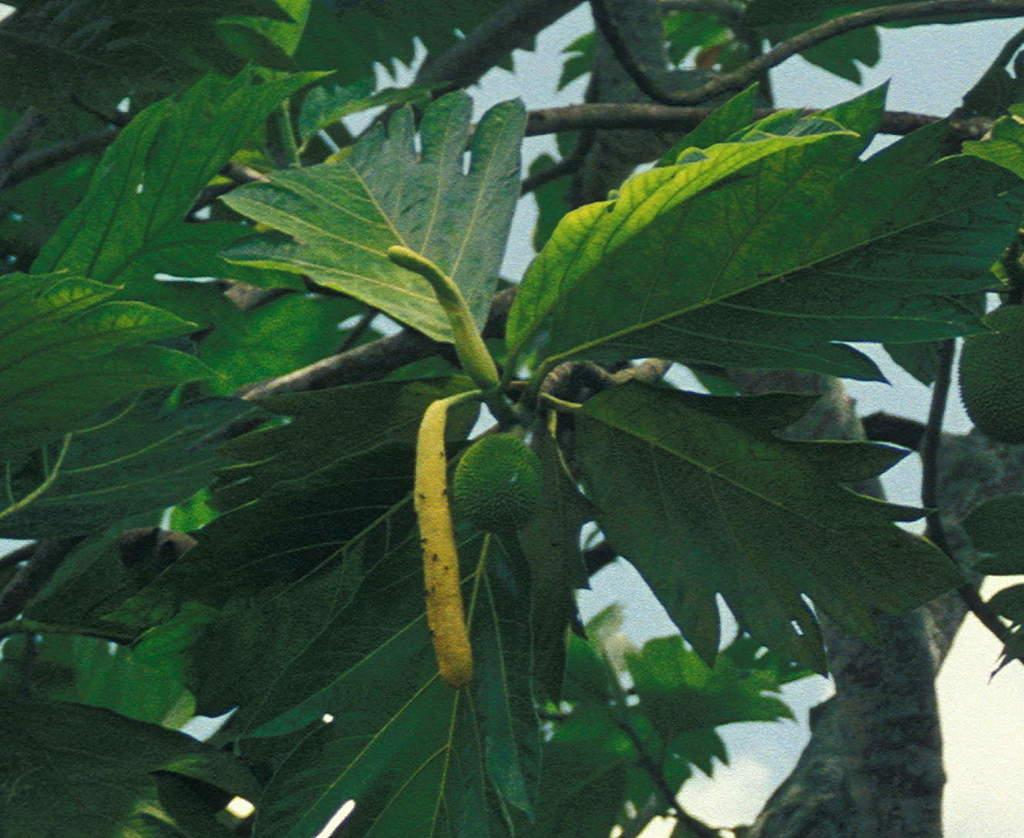What type of green color leaves can be seen in the image? There are green color leaves in the image. What other green color item is present in the image? There is a green color vegetable in the image. Can you see any bubbles in the image? There are no bubbles present in the image. What type of operation is being performed on the tooth in the image? There is no tooth or operation present in the image. 